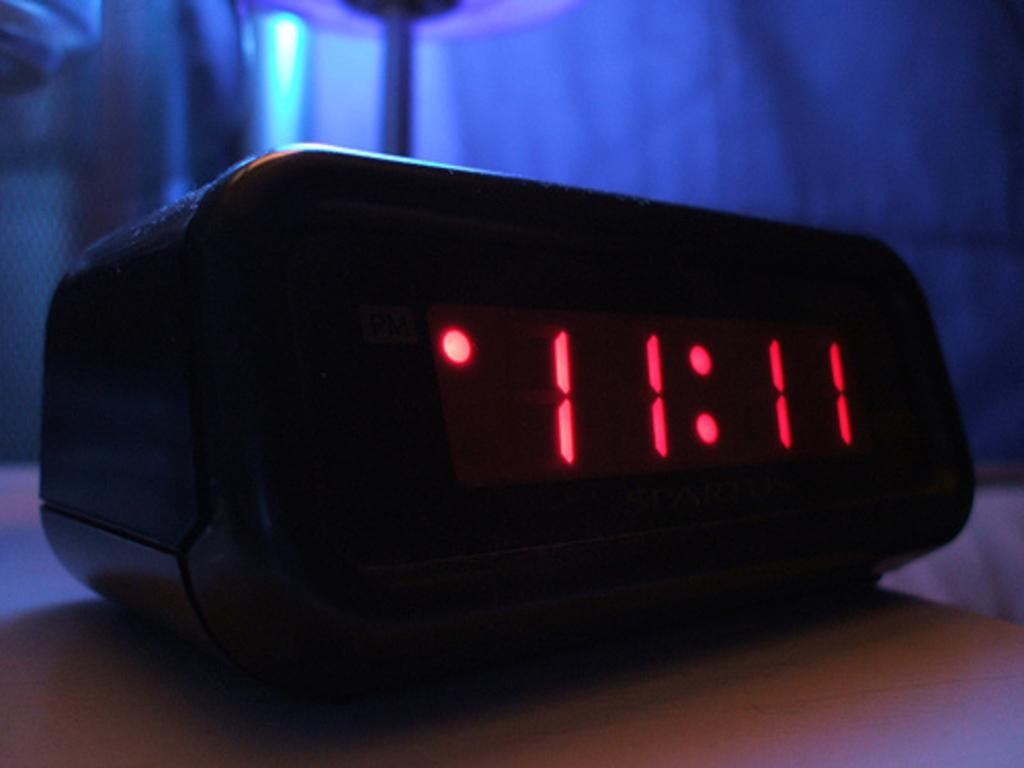<image>
Share a concise interpretation of the image provided. a digital clock with red lights set ay 11:11 